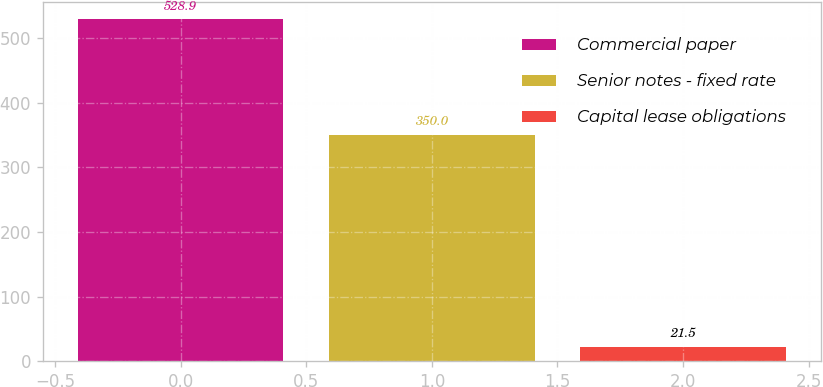Convert chart. <chart><loc_0><loc_0><loc_500><loc_500><bar_chart><fcel>Commercial paper<fcel>Senior notes - fixed rate<fcel>Capital lease obligations<nl><fcel>528.9<fcel>350<fcel>21.5<nl></chart> 